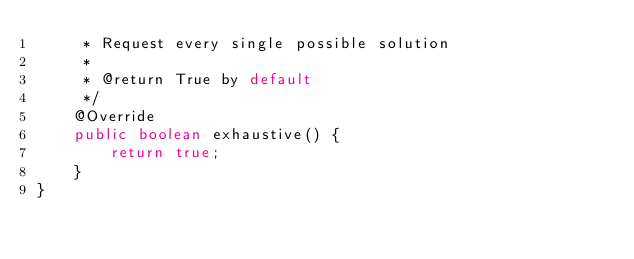<code> <loc_0><loc_0><loc_500><loc_500><_Java_>     * Request every single possible solution
     *
     * @return True by default
     */
    @Override
    public boolean exhaustive() {
        return true;
    }
}
</code> 